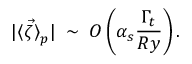Convert formula to latex. <formula><loc_0><loc_0><loc_500><loc_500>| { \langle \vec { \zeta } \rangle } _ { p } | \, \sim \, O \left ( \alpha _ { s } \frac { \Gamma _ { t } } { R y } \right ) .</formula> 